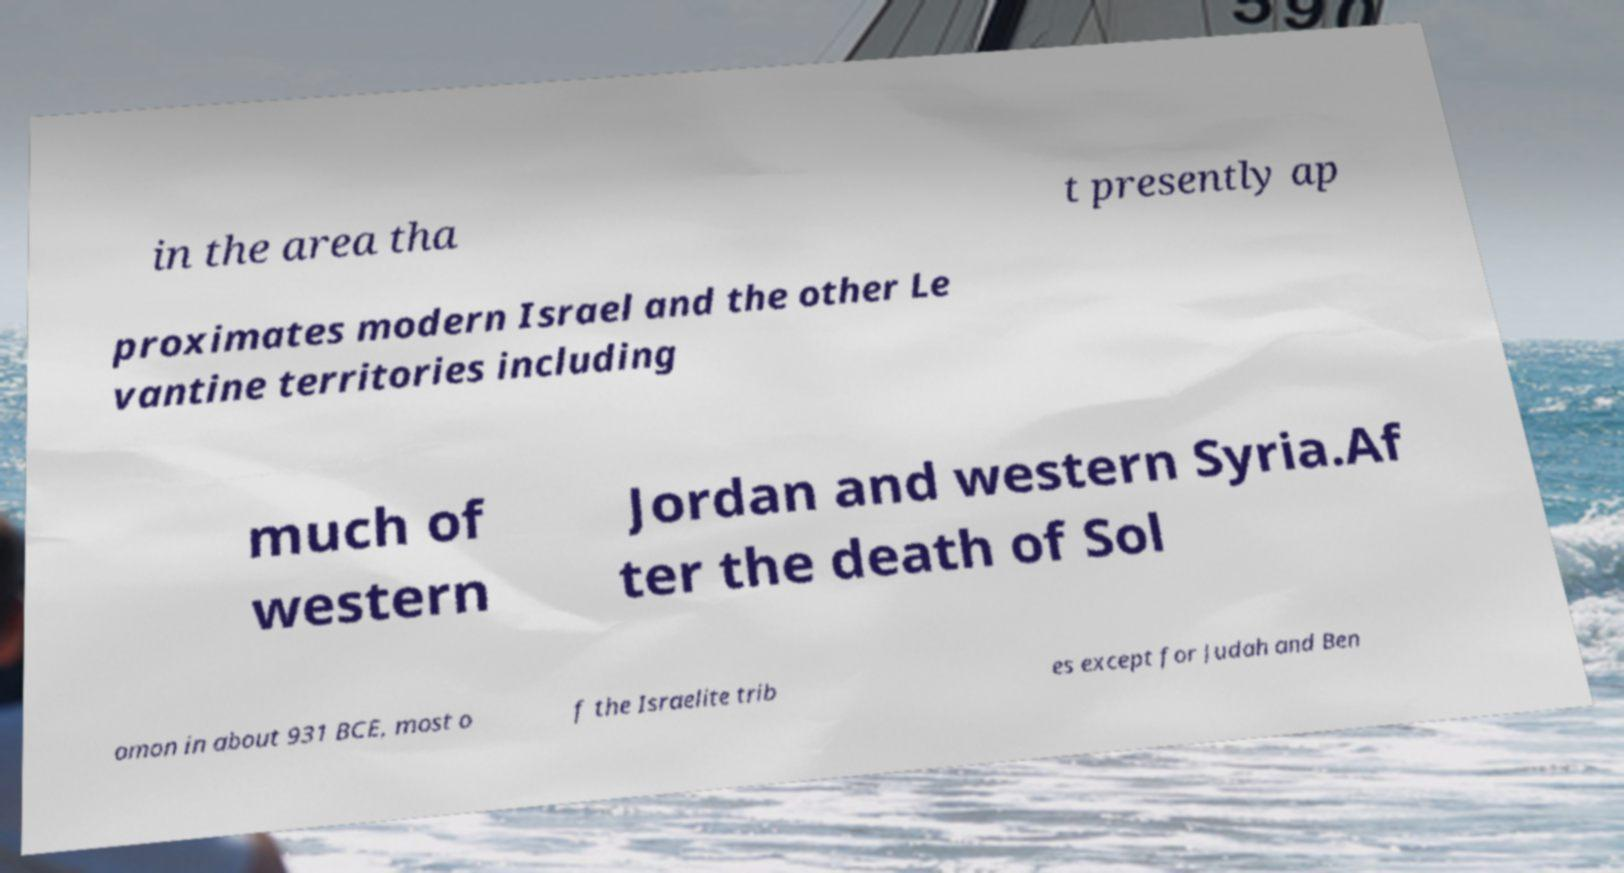There's text embedded in this image that I need extracted. Can you transcribe it verbatim? in the area tha t presently ap proximates modern Israel and the other Le vantine territories including much of western Jordan and western Syria.Af ter the death of Sol omon in about 931 BCE, most o f the Israelite trib es except for Judah and Ben 